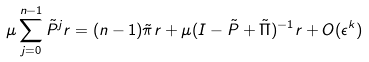<formula> <loc_0><loc_0><loc_500><loc_500>\mu \sum _ { j = 0 } ^ { n - 1 } \tilde { P } ^ { j } r = ( n - 1 ) \tilde { \pi } r + \mu ( I - \tilde { P } + \tilde { \Pi } ) ^ { - 1 } r + O ( \epsilon ^ { k } )</formula> 